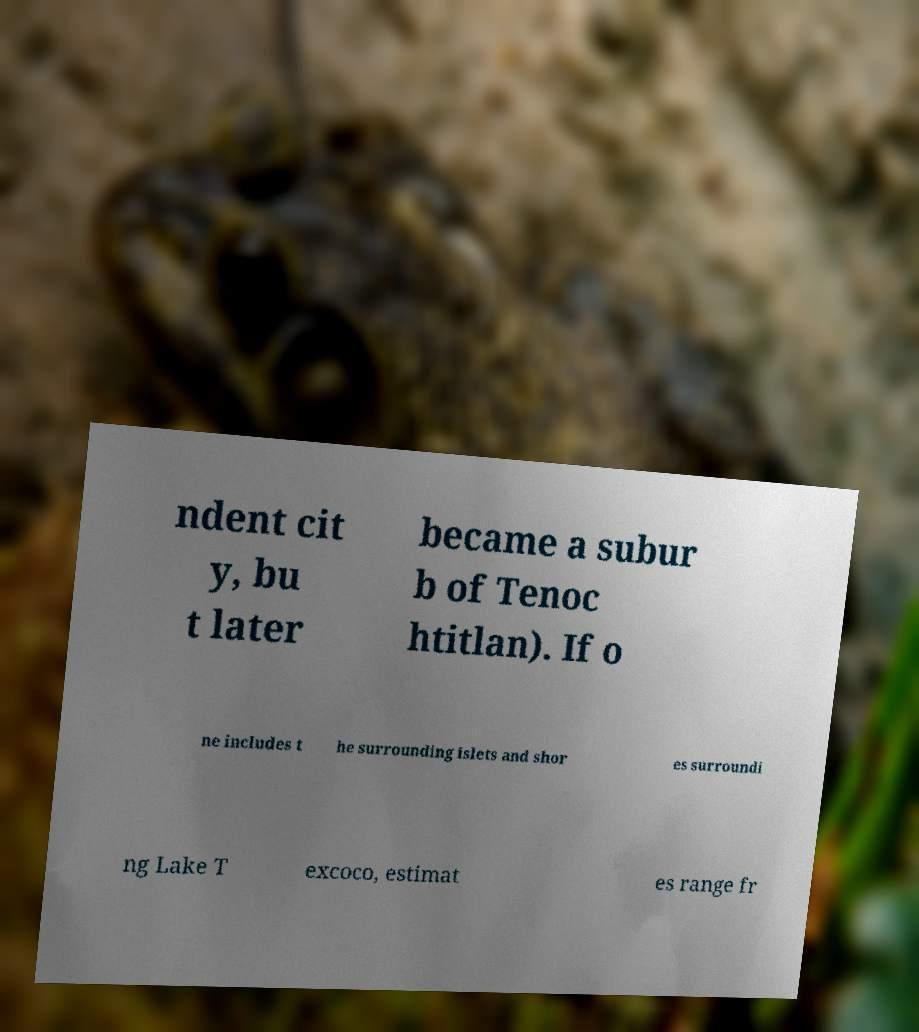For documentation purposes, I need the text within this image transcribed. Could you provide that? ndent cit y, bu t later became a subur b of Tenoc htitlan). If o ne includes t he surrounding islets and shor es surroundi ng Lake T excoco, estimat es range fr 